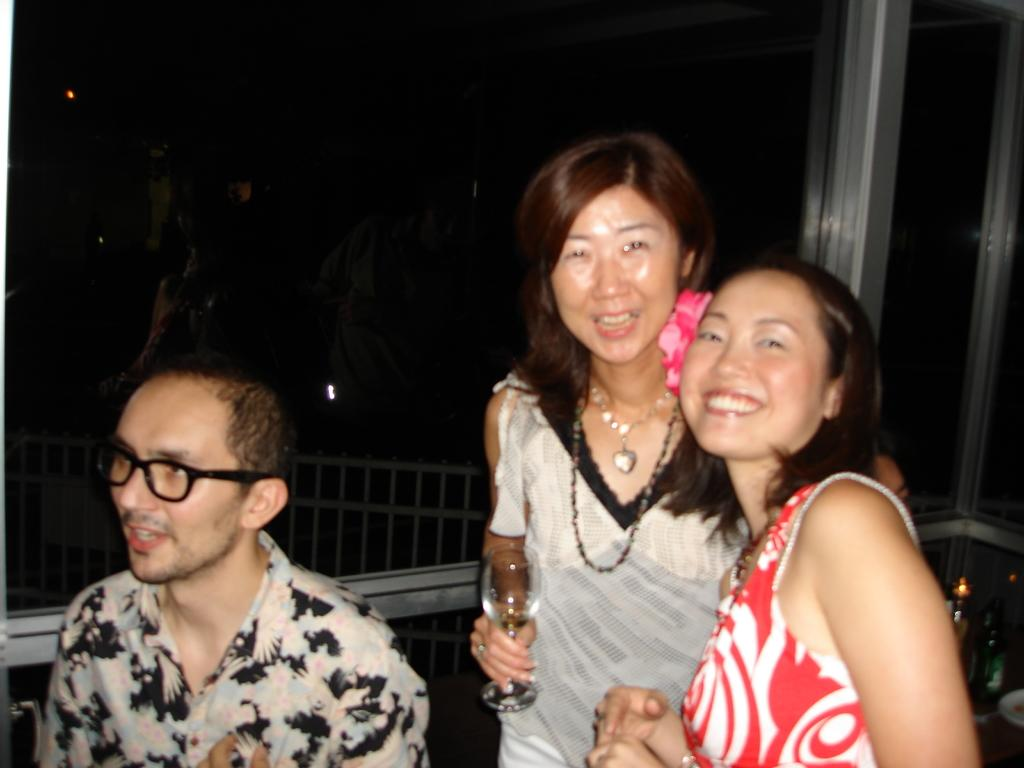How many people are in the image? There are three people in the image. What is the woman holding in the image? The woman is holding a glass. What can be seen in the background of the image? There is a fence and metal rods in the background of the image. What is the boy writing on the guide in the image? There is no boy, writing, or guide present in the image. 